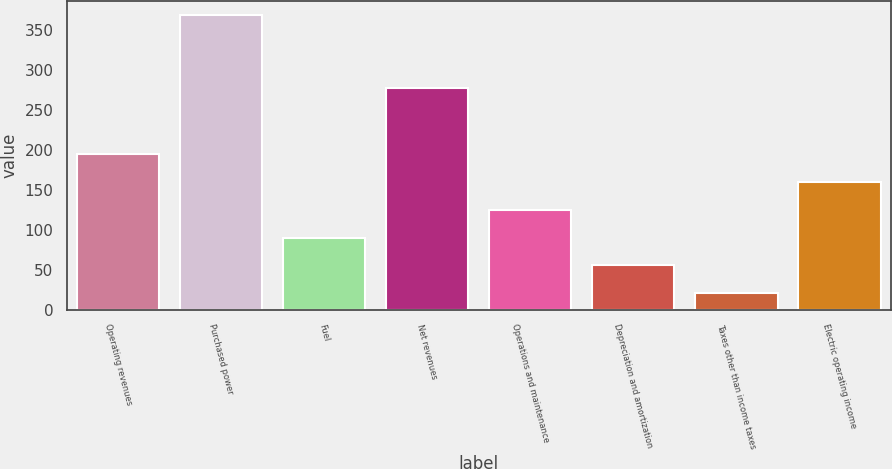Convert chart. <chart><loc_0><loc_0><loc_500><loc_500><bar_chart><fcel>Operating revenues<fcel>Purchased power<fcel>Fuel<fcel>Net revenues<fcel>Operations and maintenance<fcel>Depreciation and amortization<fcel>Taxes other than income taxes<fcel>Electric operating income<nl><fcel>195<fcel>369<fcel>90.6<fcel>278<fcel>125.4<fcel>55.8<fcel>21<fcel>160.2<nl></chart> 